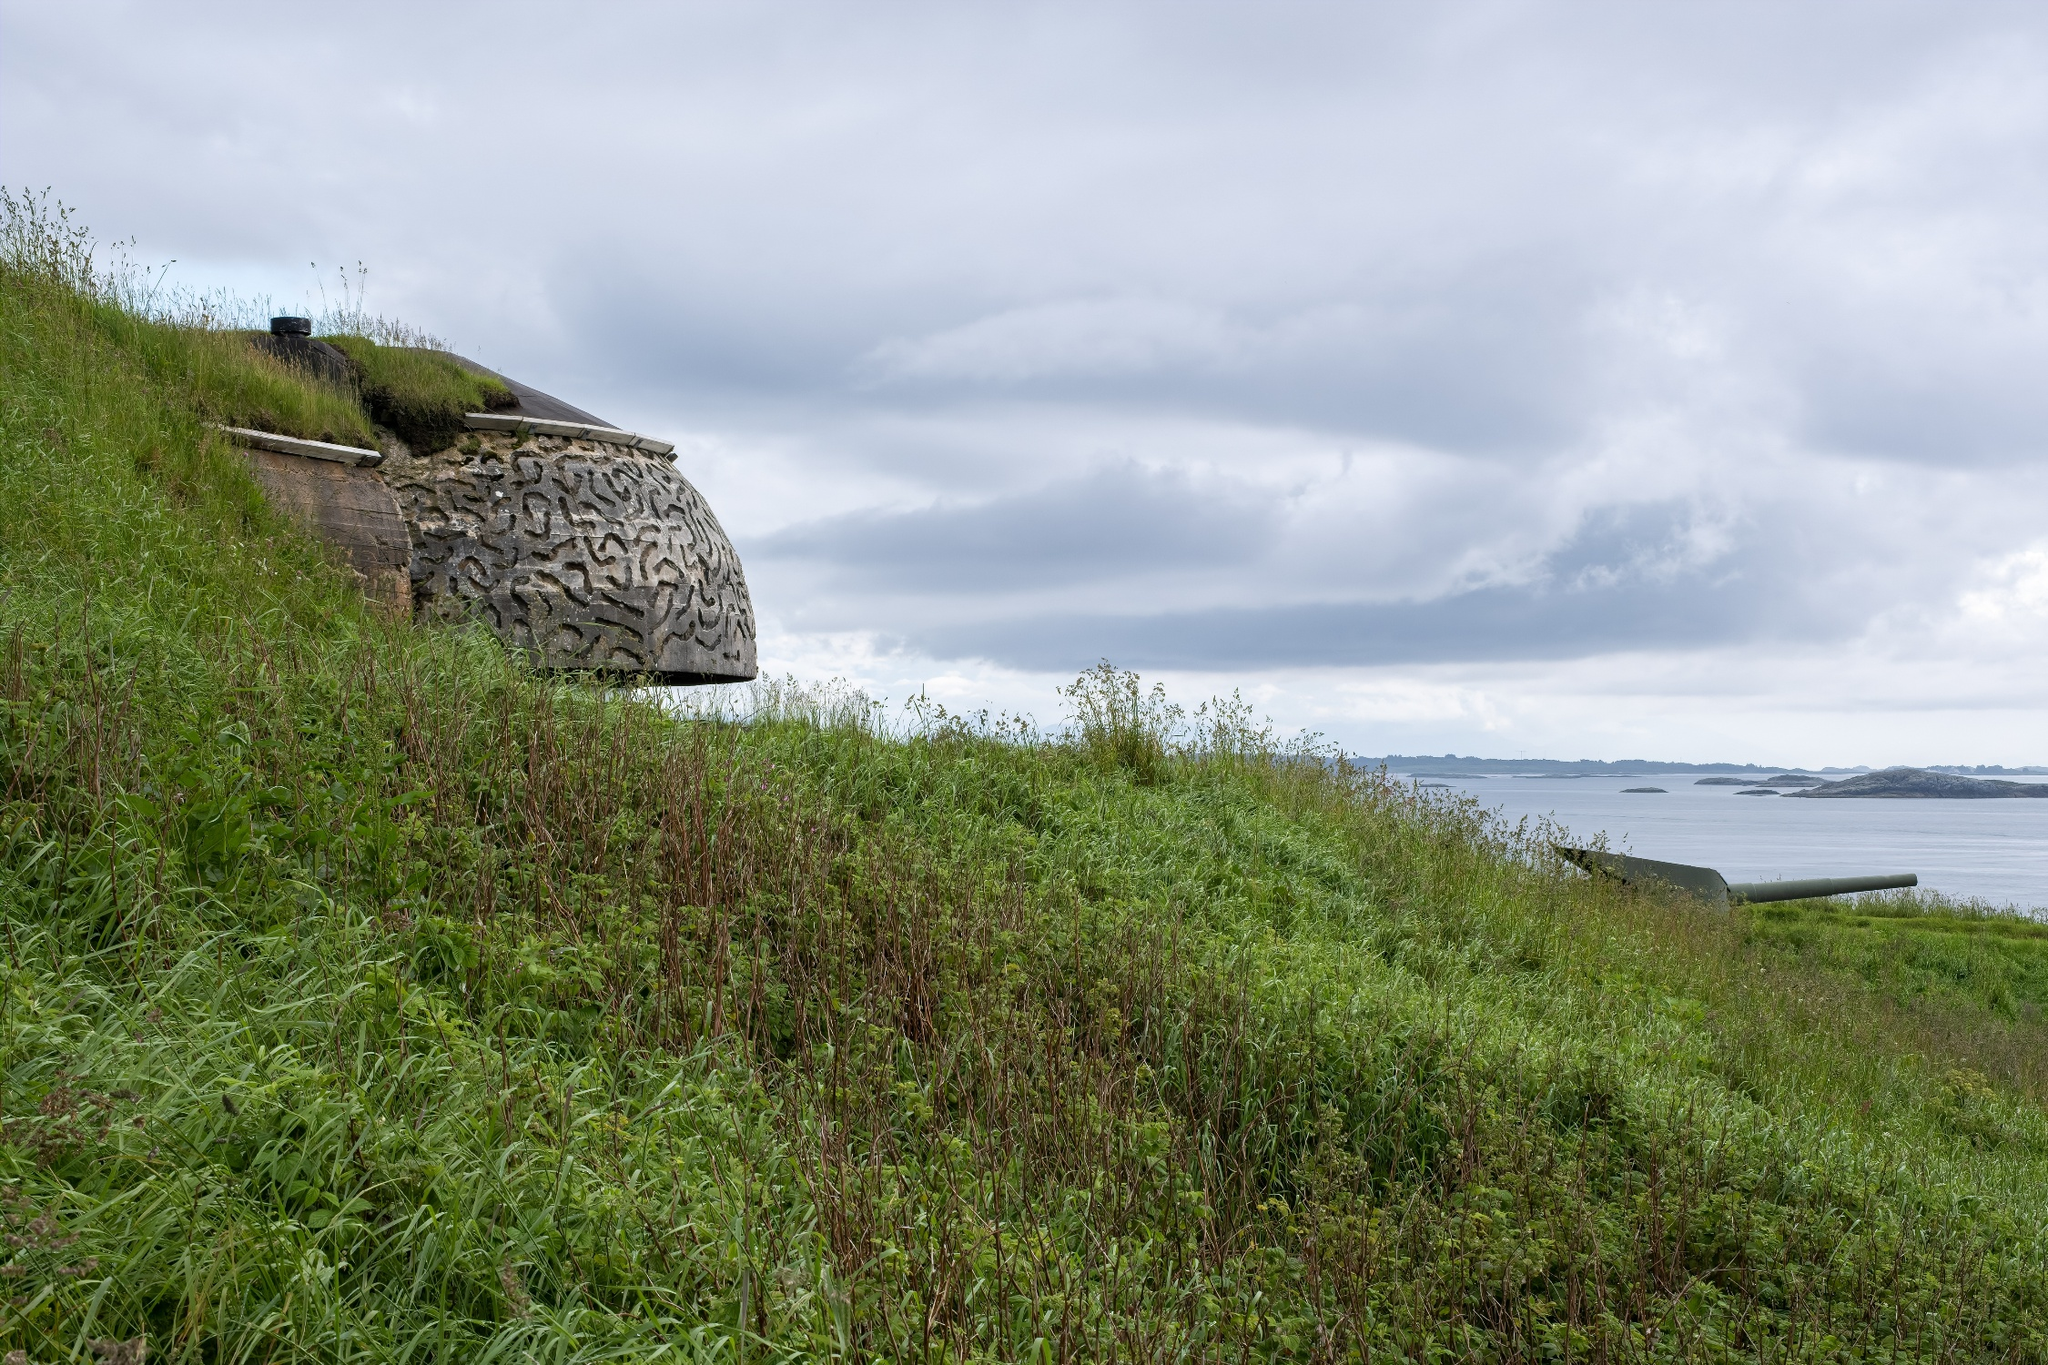How would a poet describe this landscape? Upon this hill, where verdant grasses sway,
A sentinel stands, carved in timeless gray
With lines that weave a tale of yesteryears,
Where echoed whispers blend with nature’s cheers.
The ocean sprawls, a canvas vast and deep,
Its waves and whispers lull the day to sleep.
Above, the sky, a quilt of cloud and hue,
Embraces both, with tender morning dew.
In this serene embrace of earth and sea,
Tranquility breathes, as time’s sweet meddle be. 